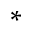<formula> <loc_0><loc_0><loc_500><loc_500>^ { * }</formula> 